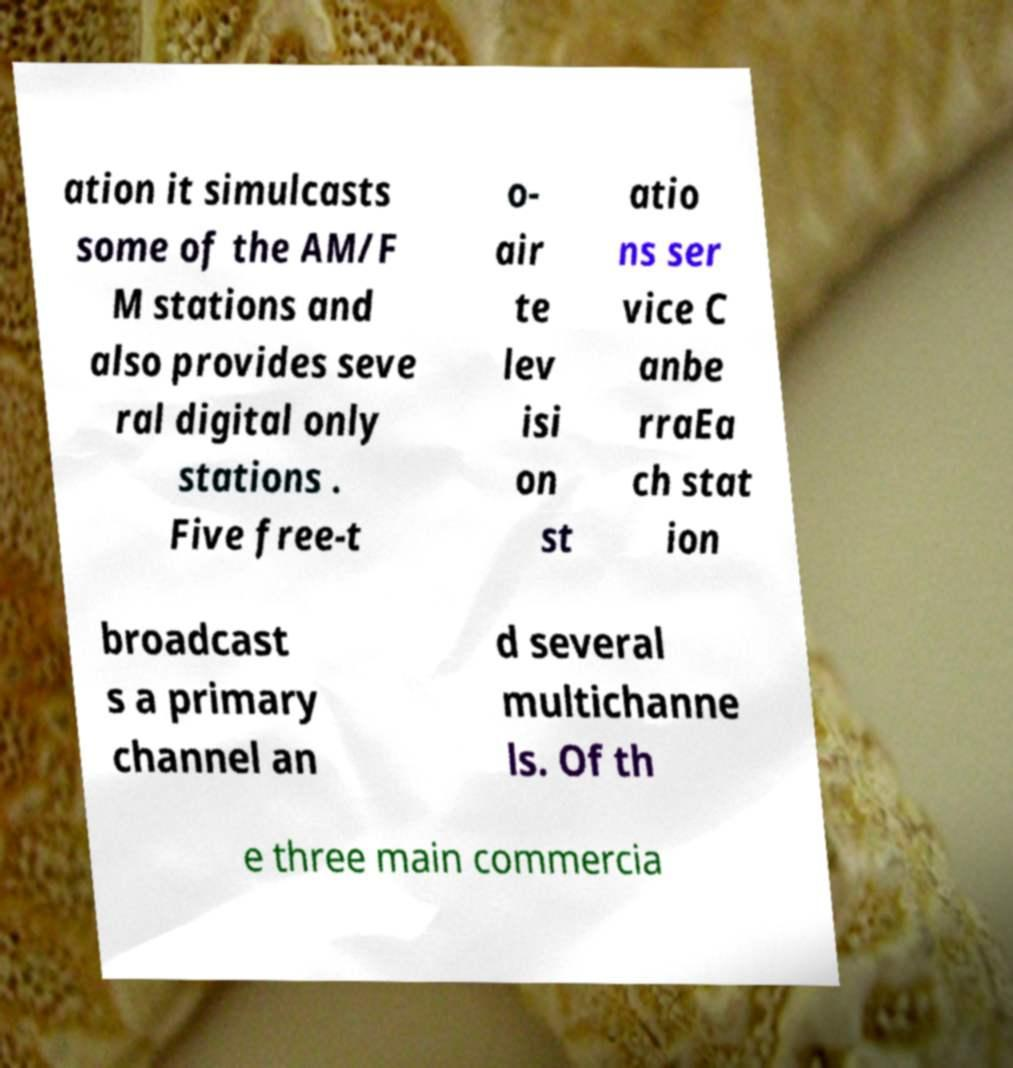Please read and relay the text visible in this image. What does it say? ation it simulcasts some of the AM/F M stations and also provides seve ral digital only stations . Five free-t o- air te lev isi on st atio ns ser vice C anbe rraEa ch stat ion broadcast s a primary channel an d several multichanne ls. Of th e three main commercia 